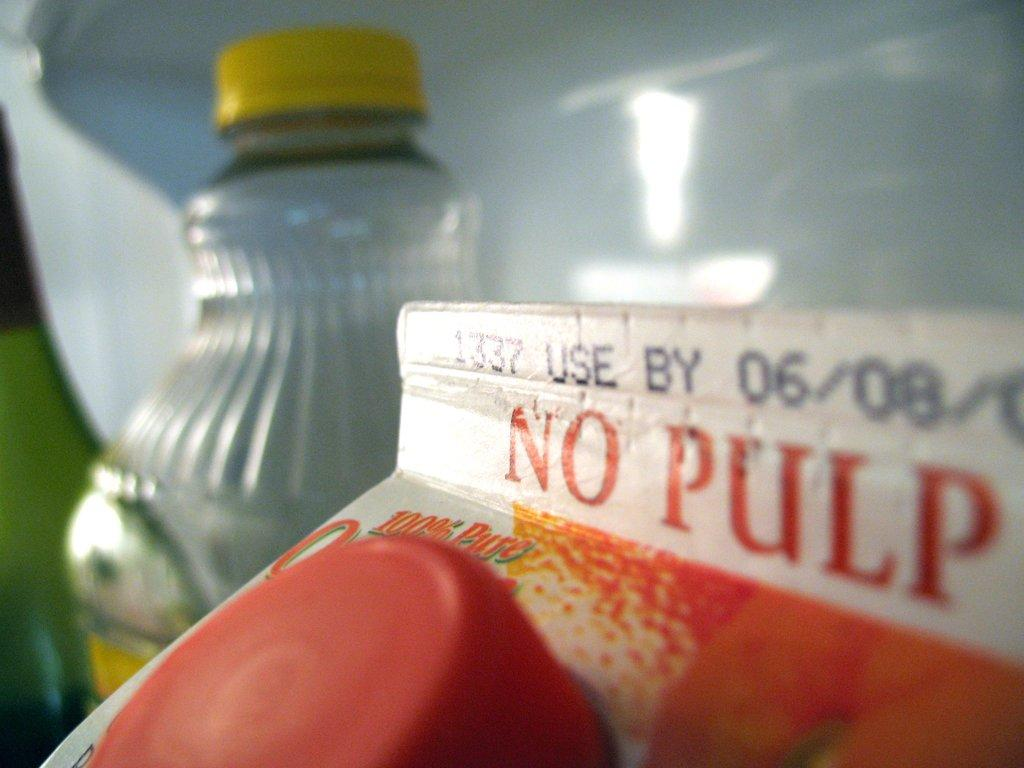What is the main object in the image? There is a juice packer in the image. What feature does the juice packer have? The juice packer has a cap. Is there any text or writing on the juice packer? Yes, there is writing on the juice packer. Can you describe anything else visible in the background of the image? There is a bottle with a yellow cap in the background of the image. Where are your friends located in the image? There are no friends present in the image; it only features a juice packer and a bottle with a yellow cap. Can you tell me how many gravestones are visible in the image? There are no gravestones or cemeteries present in the image; it only features a juice packer and a bottle with a yellow cap. 